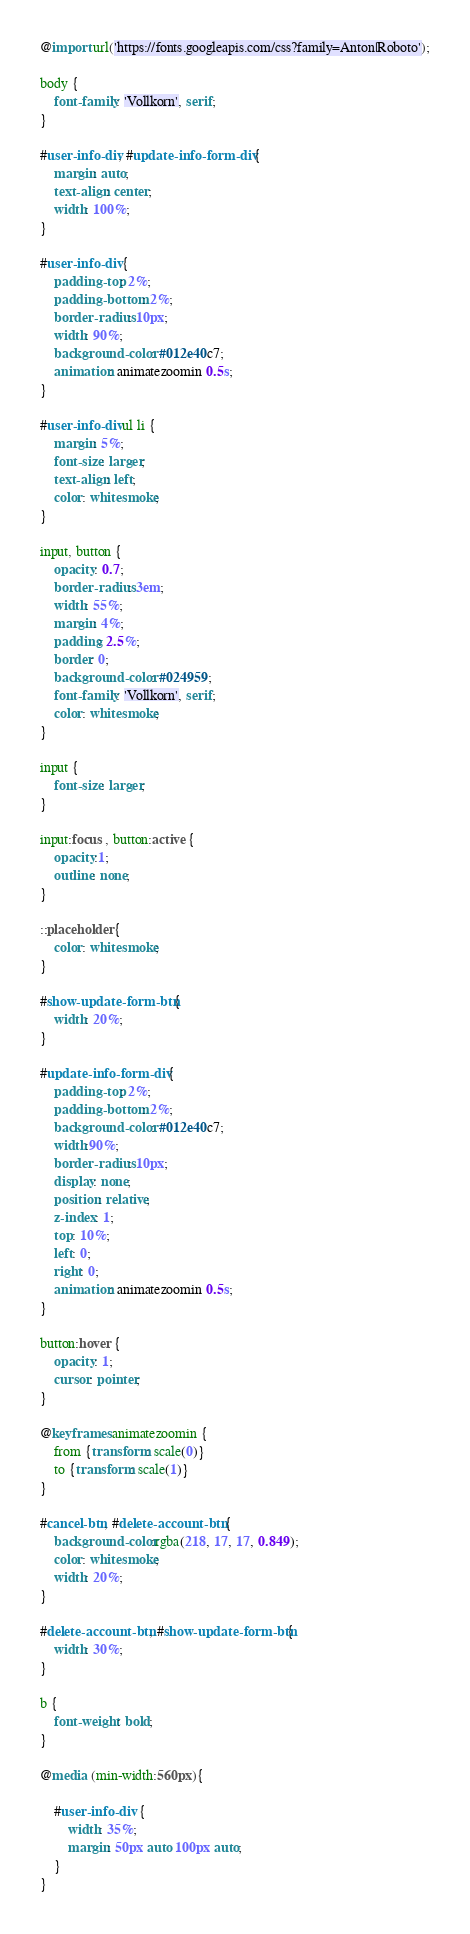Convert code to text. <code><loc_0><loc_0><loc_500><loc_500><_CSS_>@import url('https://fonts.googleapis.com/css?family=Anton|Roboto');

body {
    font-family: 'Vollkorn', serif;
}

#user-info-div, #update-info-form-div {
    margin: auto;
    text-align: center;
    width: 100%;
}

#user-info-div {
    padding-top: 2%;
    padding-bottom: 2%;
    border-radius: 10px;
    width: 90%;
    background-color: #012e40c7;
    animation: animatezoomin 0.5s;
}

#user-info-div ul li {
    margin: 5%;
    font-size: larger;
    text-align: left;
    color: whitesmoke;
}

input, button {
    opacity: 0.7;
    border-radius: 3em;
    width: 55%;
    margin: 4%;
    padding: 2.5%;
    border: 0;
    background-color: #024959;
    font-family: 'Vollkorn', serif;
    color: whitesmoke;
}

input {
    font-size: larger;
}

input:focus , button:active {
    opacity:1;
    outline: none;
}

::placeholder { 
    color: whitesmoke;
}    

#show-update-form-btn {
    width: 20%;
}

#update-info-form-div {
    padding-top: 2%;
    padding-bottom: 2%; 
    background-color: #012e40c7;
    width:90%;
    border-radius: 10px;
    display: none;
    position: relative;
    z-index: 1;
    top: 10%;
    left: 0;
    right: 0;
    animation: animatezoomin 0.5s;
}

button:hover {
    opacity: 1;
    cursor: pointer;
}
    
@keyframes animatezoomin {
    from {transform: scale(0)} 
    to {transform: scale(1)}
}

#cancel-btn, #delete-account-btn {
    background-color:rgba(218, 17, 17, 0.849);
    color: whitesmoke;
    width: 20%;
}

#delete-account-btn, #show-update-form-btn{
    width: 30%;
}

b {
    font-weight: bold;
}

@media (min-width:560px){

    #user-info-div  {
        width: 35%;
        margin: 50px auto 100px auto;
    }
}</code> 